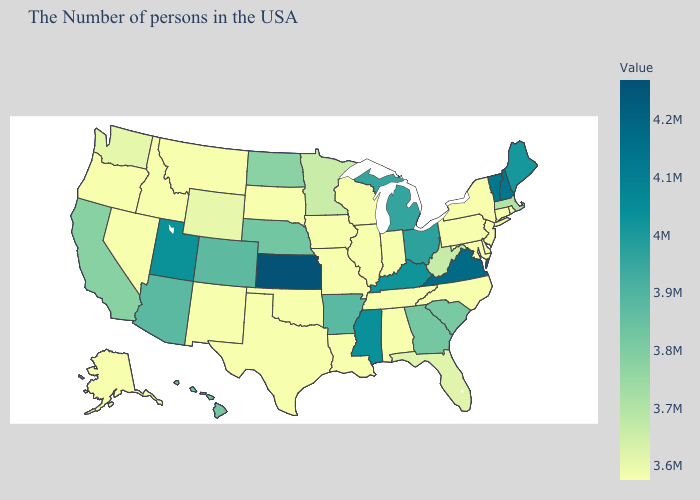Which states have the lowest value in the South?
Quick response, please. Delaware, Maryland, North Carolina, Alabama, Tennessee, Louisiana, Texas. Does Tennessee have the lowest value in the USA?
Short answer required. Yes. Which states have the lowest value in the South?
Keep it brief. Delaware, Maryland, North Carolina, Alabama, Tennessee, Louisiana, Texas. Is the legend a continuous bar?
Concise answer only. Yes. Is the legend a continuous bar?
Concise answer only. Yes. 